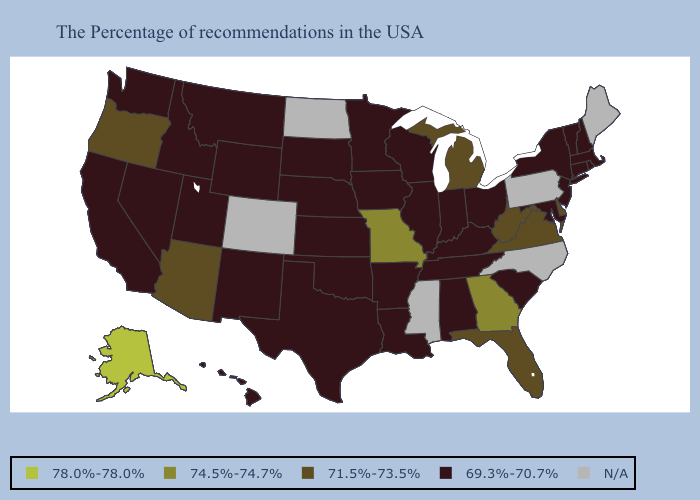What is the value of North Carolina?
Keep it brief. N/A. Among the states that border New Jersey , does Delaware have the lowest value?
Answer briefly. No. How many symbols are there in the legend?
Answer briefly. 5. What is the highest value in the MidWest ?
Give a very brief answer. 74.5%-74.7%. Among the states that border Maine , which have the lowest value?
Write a very short answer. New Hampshire. What is the value of South Dakota?
Give a very brief answer. 69.3%-70.7%. Is the legend a continuous bar?
Short answer required. No. What is the value of Maine?
Write a very short answer. N/A. Does Texas have the highest value in the South?
Short answer required. No. Is the legend a continuous bar?
Concise answer only. No. Name the states that have a value in the range 78.0%-78.0%?
Quick response, please. Alaska. What is the highest value in the South ?
Answer briefly. 74.5%-74.7%. Name the states that have a value in the range N/A?
Write a very short answer. Maine, Pennsylvania, North Carolina, Mississippi, North Dakota, Colorado. What is the value of Arkansas?
Concise answer only. 69.3%-70.7%. 